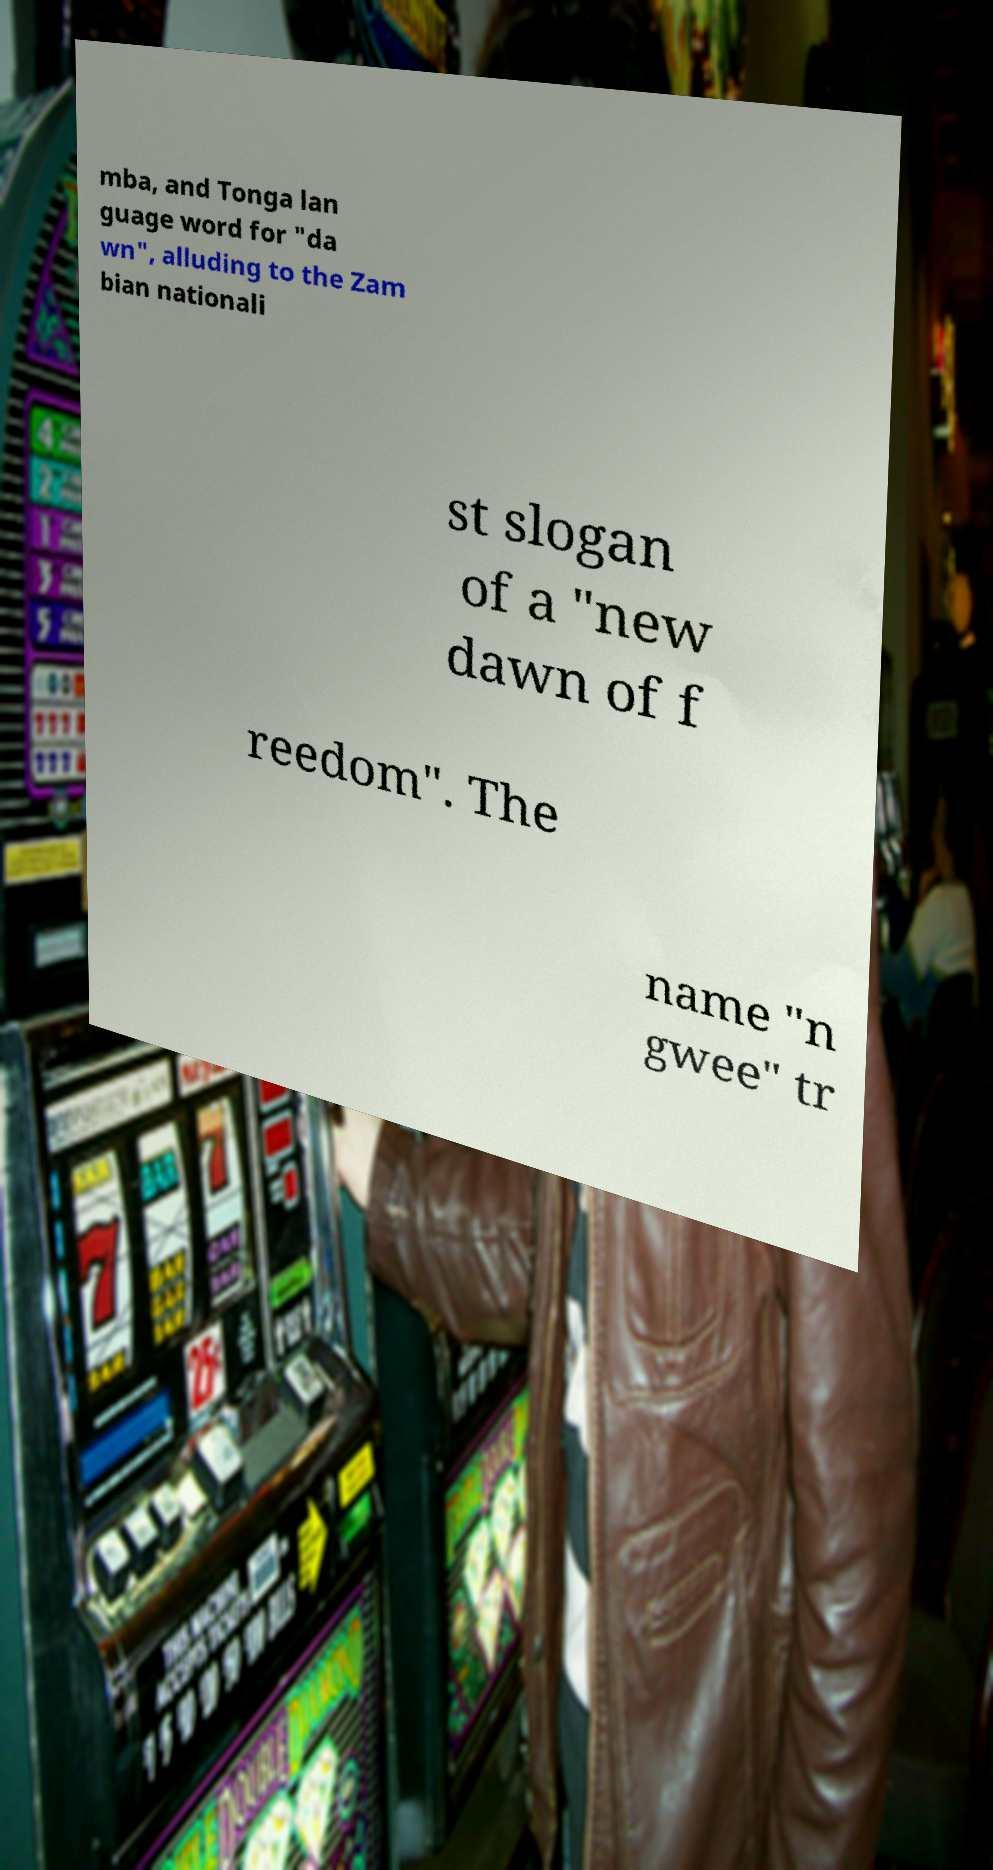What messages or text are displayed in this image? I need them in a readable, typed format. mba, and Tonga lan guage word for "da wn", alluding to the Zam bian nationali st slogan of a "new dawn of f reedom". The name "n gwee" tr 